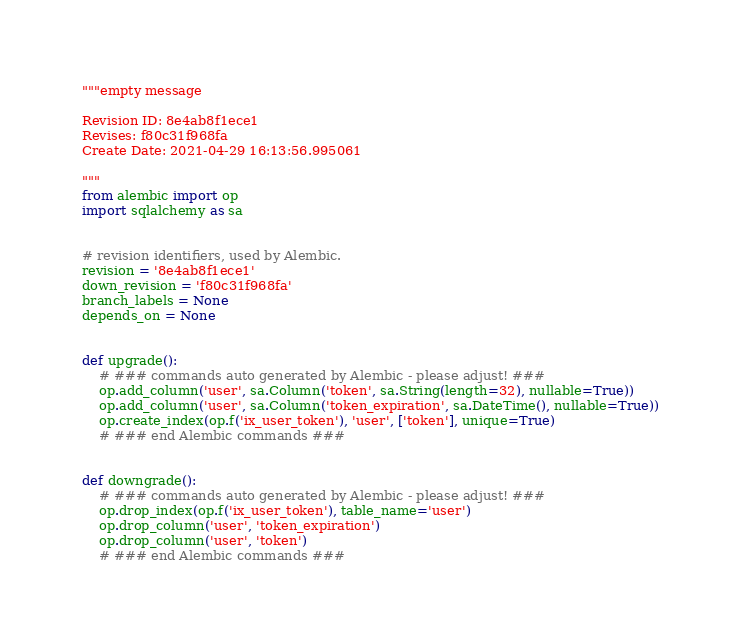<code> <loc_0><loc_0><loc_500><loc_500><_Python_>"""empty message

Revision ID: 8e4ab8f1ece1
Revises: f80c31f968fa
Create Date: 2021-04-29 16:13:56.995061

"""
from alembic import op
import sqlalchemy as sa


# revision identifiers, used by Alembic.
revision = '8e4ab8f1ece1'
down_revision = 'f80c31f968fa'
branch_labels = None
depends_on = None


def upgrade():
    # ### commands auto generated by Alembic - please adjust! ###
    op.add_column('user', sa.Column('token', sa.String(length=32), nullable=True))
    op.add_column('user', sa.Column('token_expiration', sa.DateTime(), nullable=True))
    op.create_index(op.f('ix_user_token'), 'user', ['token'], unique=True)
    # ### end Alembic commands ###


def downgrade():
    # ### commands auto generated by Alembic - please adjust! ###
    op.drop_index(op.f('ix_user_token'), table_name='user')
    op.drop_column('user', 'token_expiration')
    op.drop_column('user', 'token')
    # ### end Alembic commands ###
</code> 